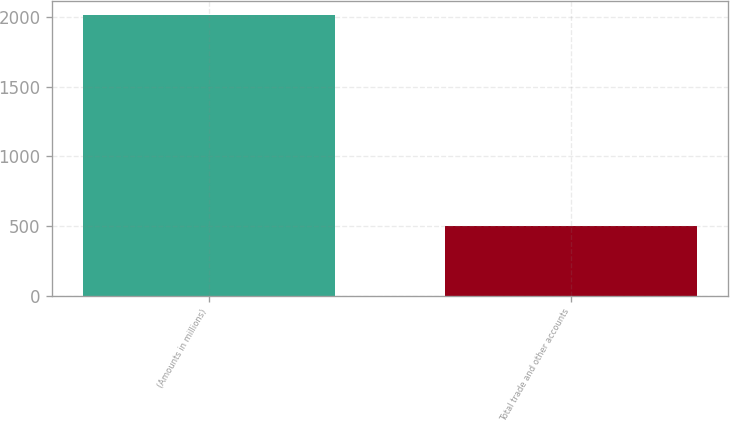<chart> <loc_0><loc_0><loc_500><loc_500><bar_chart><fcel>(Amounts in millions)<fcel>Total trade and other accounts<nl><fcel>2012<fcel>497.9<nl></chart> 